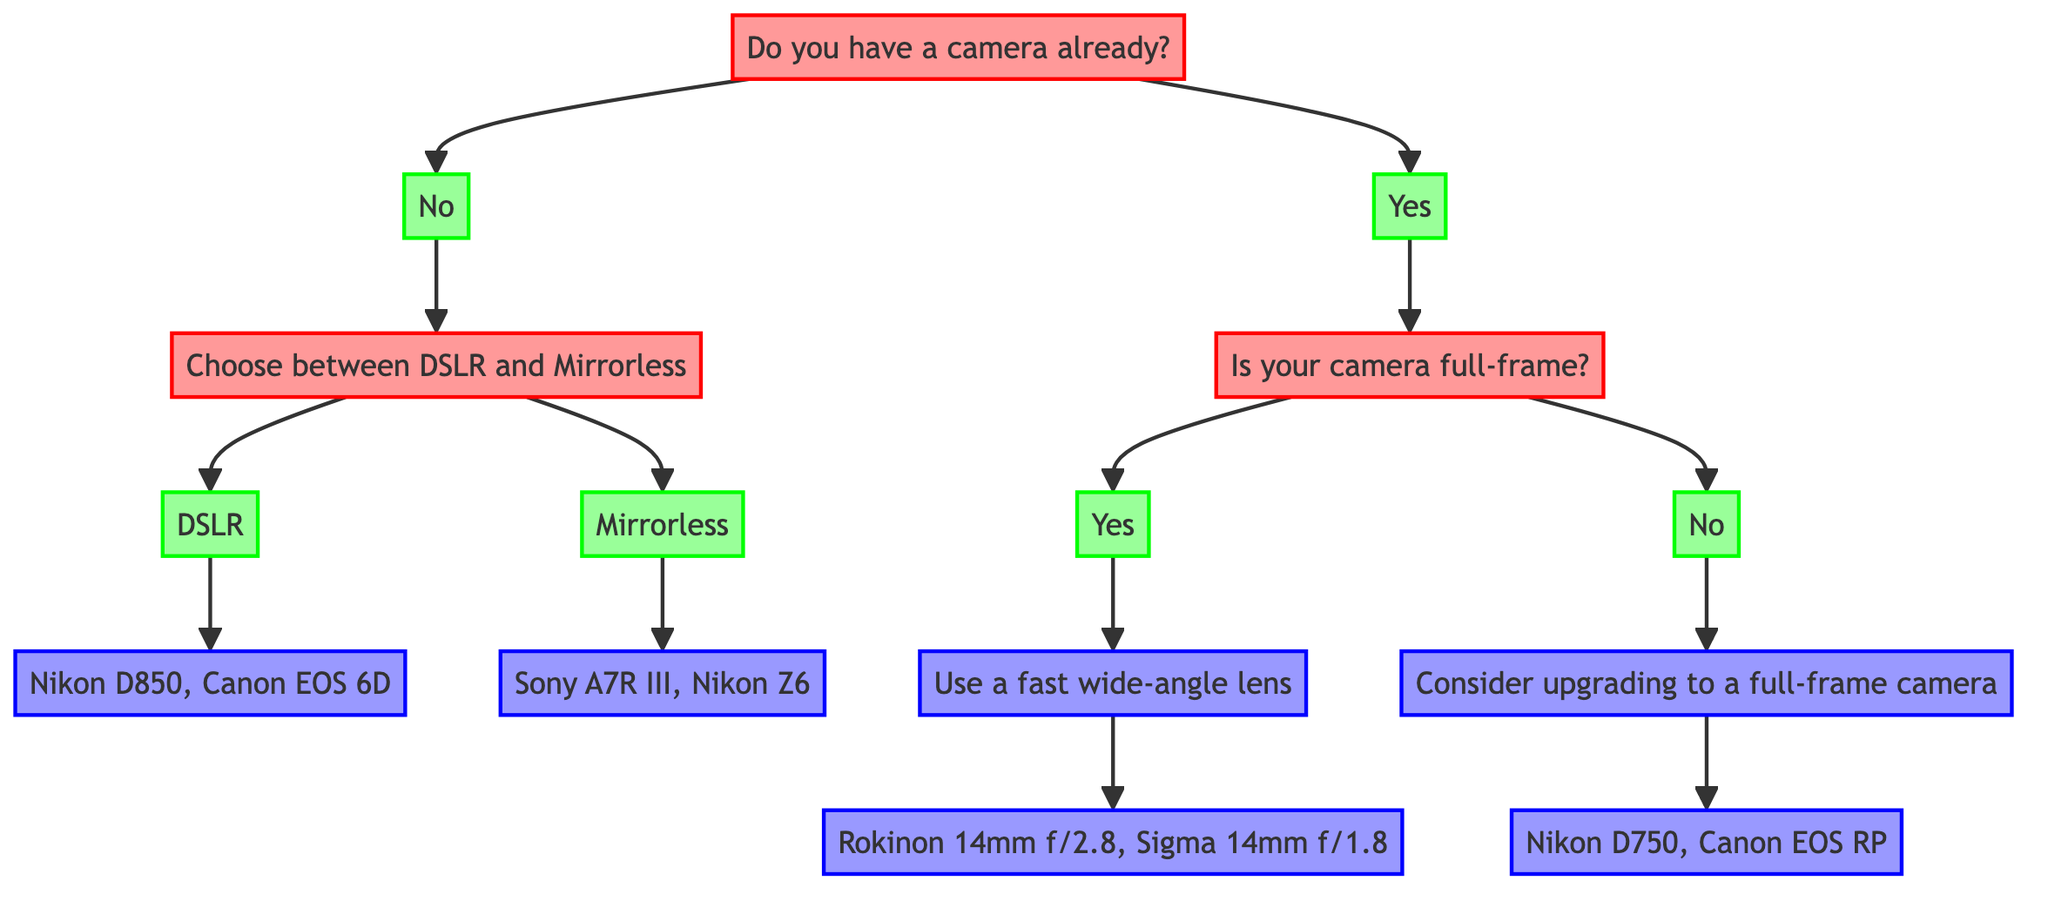What is the first question in the diagram? The first question in the diagram is about whether the user has a camera already. It is the starting point for any further decisions in the flow.
Answer: Do you have a camera already? What are two recommended DSLR models? If the user chooses the DSLR path after selecting that they do not have a camera, the recommendation ends with the Nikon D850 and Canon EOS 6D.
Answer: Nikon D850, Canon EOS 6D How many options are available for camera types if the user does not have a camera? After the first question about having a camera, the user can choose between two options, DSLR and Mirrorless, leading to a total of 2 options.
Answer: 2 What type of lens should a full-frame camera user choose? For users with a full-frame camera, the recommendation is to use a fast wide-angle lens which is explicitly mentioned at that stage of the diagram.
Answer: Use a fast wide-angle lens What is a recommendation for someone with a non-full-frame camera? The flow indicates that a user with a non-full-frame camera should consider upgrading to a full-frame camera, as noted in the diagram after the relevant question.
Answer: Consider upgrading to a full-frame camera How many total recommendations are there for lens types? The diagram has two specific recommendations for lens types which are Rokinon 14mm f/2.8 and Sigma 14mm f/1.8, both listed under the same flow.
Answer: 2 What is the relationship between having a camera and choosing a lens? The relationship is sequential; whether the user has a camera determines the kind of recommendations provided, specifically leading to lens choices based on the camera's full-frame status.
Answer: Sequential What follows if a user selects "Yes" to having a camera? The next question that follows is whether the camera is full-frame, directing the user to different recommendations depending on this answer.
Answer: Is your camera full-frame? Which camera models are suggested for Mirrorless users? After choosing Mirrorless, the recommendation ends with Sony A7R III and Nikon Z6, which are specifically stated in the diagram for this camera type.
Answer: Sony A7R III, Nikon Z6 